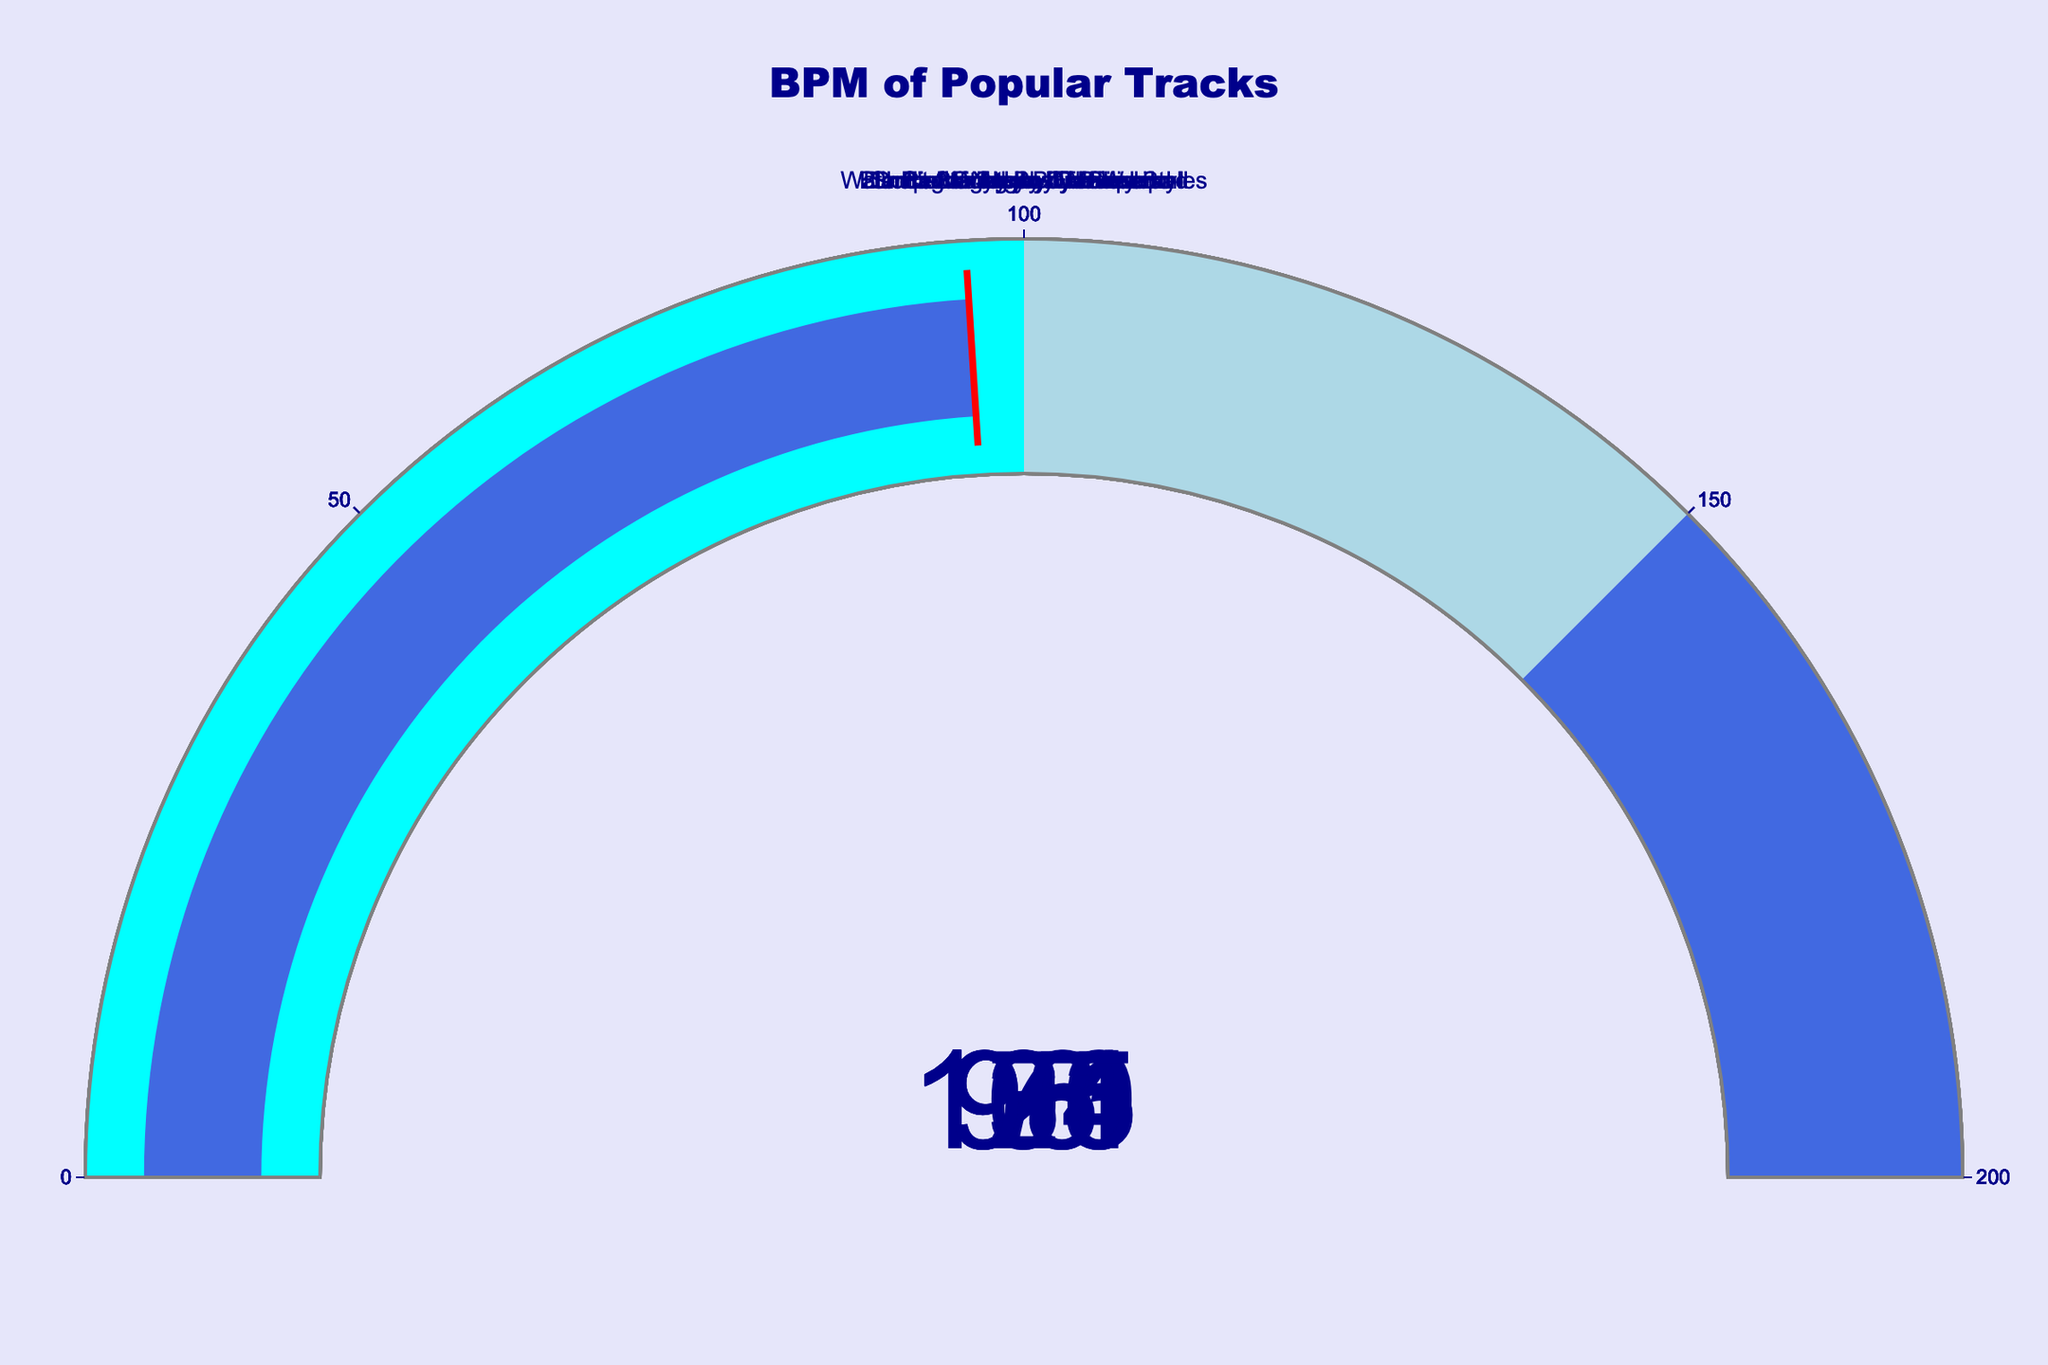What is the BPM of "Blinding Lights" by The Weeknd? The gauge chart for "Blinding Lights" by The Weeknd shows a BPM value displayed in the center of the gauge.
Answer: 171 Which track has the lowest BPM? By observing all the gauges and comparing the BPM values, "Watermelon Sugar" by Harry Styles has the lowest BPM at 95.
Answer: "Watermelon Sugar" by Harry Styles What is the average BPM of the tracks listed? Sum the BPM of all tracks and divide by the number of tracks: (171 + 124 + 120 + 98 + 103 + 135 + 95 + 96) / 8 = 941 / 8 = 117.625.
Answer: 117.625 Which track has a higher BPM, “Don't Start Now” by Dua Lipa or “Circles” by Post Malone? Compare the BPM values of both tracks. "Don't Start Now" has a BPM of 124 and "Circles" has a BPM of 120.
Answer: "Don't Start Now" by Dua Lipa How many tracks have a BPM above 100? Count the number of gauges with BPM values higher than 100. The tracks "Blinding Lights", "Don't Start Now", "Levitating", and "Bad Guy" have BPMs above 100.
Answer: 4 Which track falls within the BPM range of 90-100? Identify gauges whose BPM values fall between 90 and 100. The tracks "Dance Monkey", "Watermelon Sugar", and "Shape of You" fall within this range.
Answer: "Dance Monkey", "Watermelon Sugar", "Shape of You" What is the BPM difference between "Levitating" by Dua Lipa and “Bad Guy” by Billie Eilish? Subtract the BPM of “Levitating” from “Bad Guy”: 135 - 103 = 32.
Answer: 32 